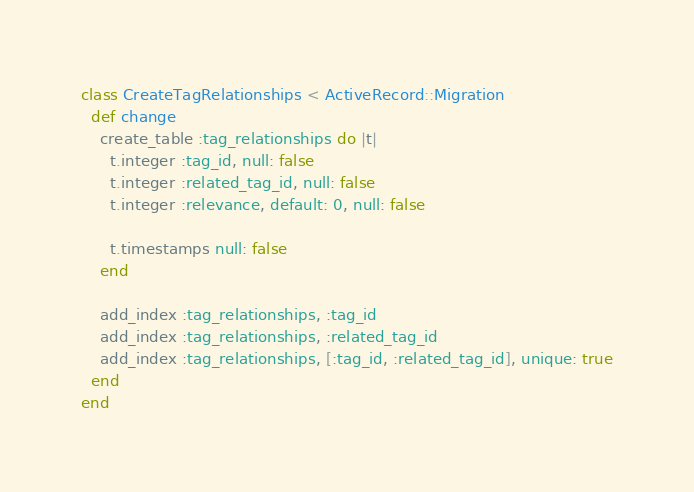<code> <loc_0><loc_0><loc_500><loc_500><_Ruby_>class CreateTagRelationships < ActiveRecord::Migration
  def change
    create_table :tag_relationships do |t|
      t.integer :tag_id, null: false
      t.integer :related_tag_id, null: false
      t.integer :relevance, default: 0, null: false

      t.timestamps null: false
    end

    add_index :tag_relationships, :tag_id
    add_index :tag_relationships, :related_tag_id
    add_index :tag_relationships, [:tag_id, :related_tag_id], unique: true
  end
end
</code> 